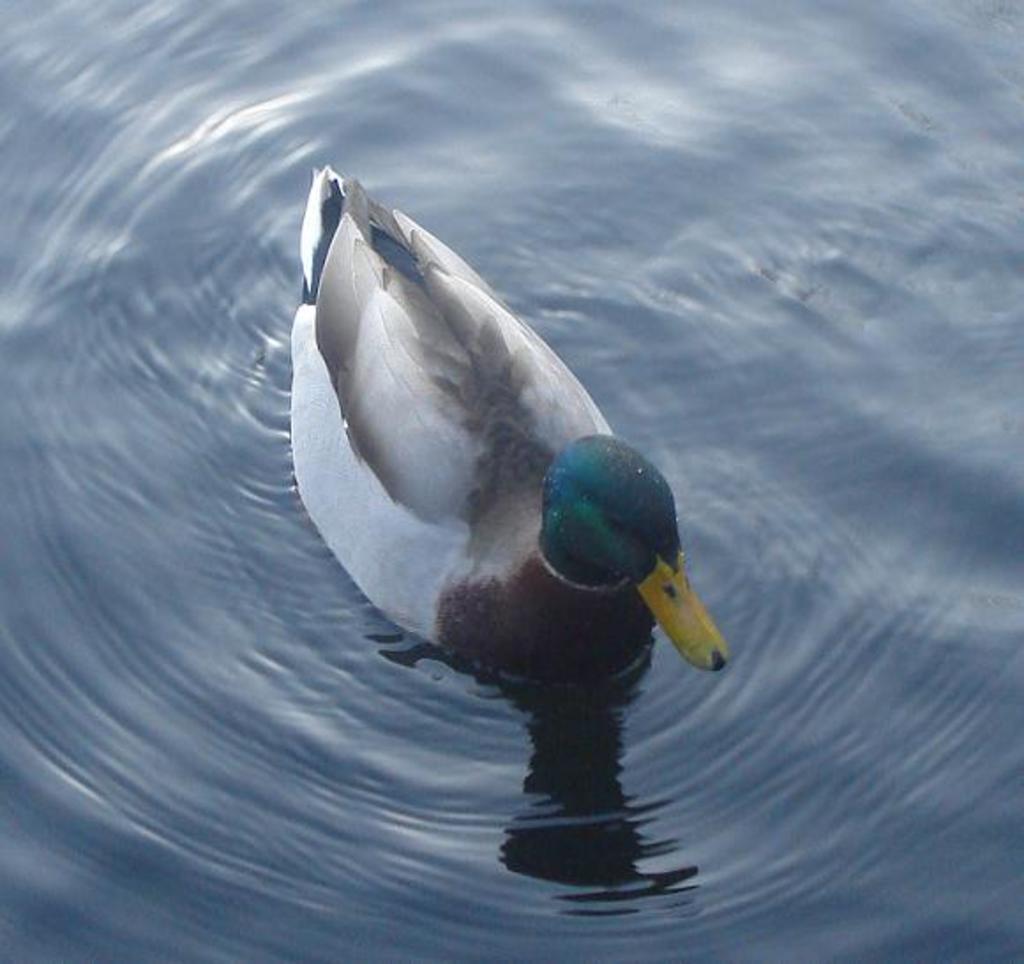Describe this image in one or two sentences. This picture shows a duck in the water. it is white, black and blue in color. 